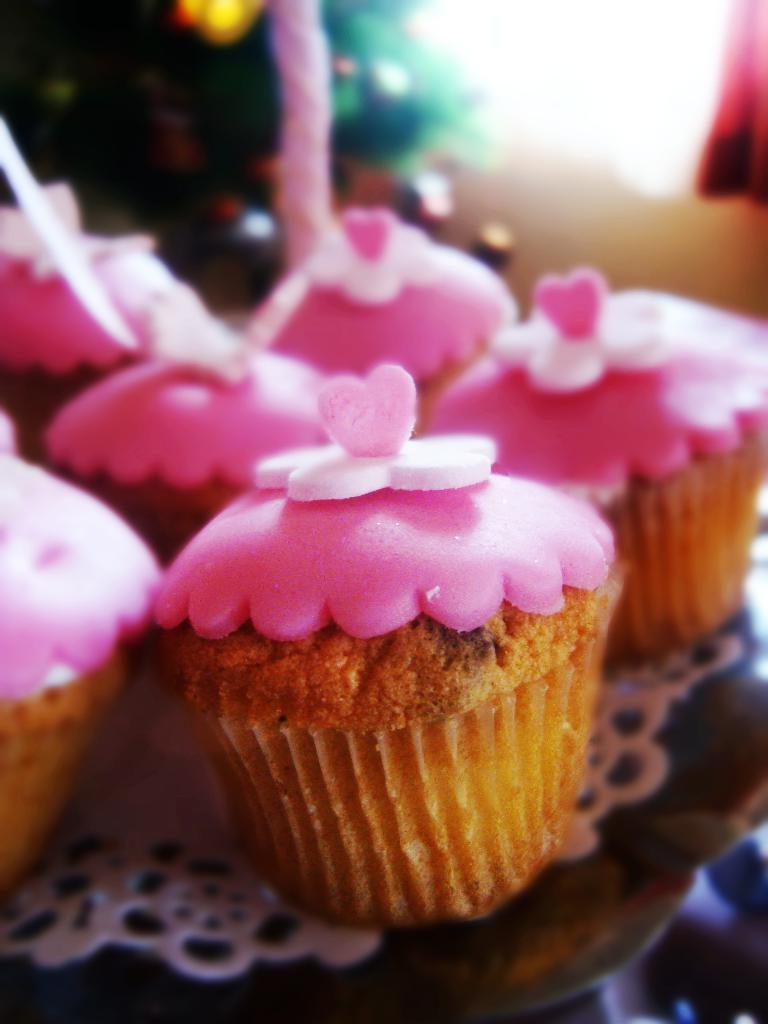What type of dessert can be seen in the image? There are cupcakes in the image. What decorations are on the cupcakes? The cupcakes have candies on them. Can you describe the background of the image? The background of the image is blurred. What type of furniture is visible in the image? There is no furniture present in the image; it features cupcakes with candies on them and a blurred background. 